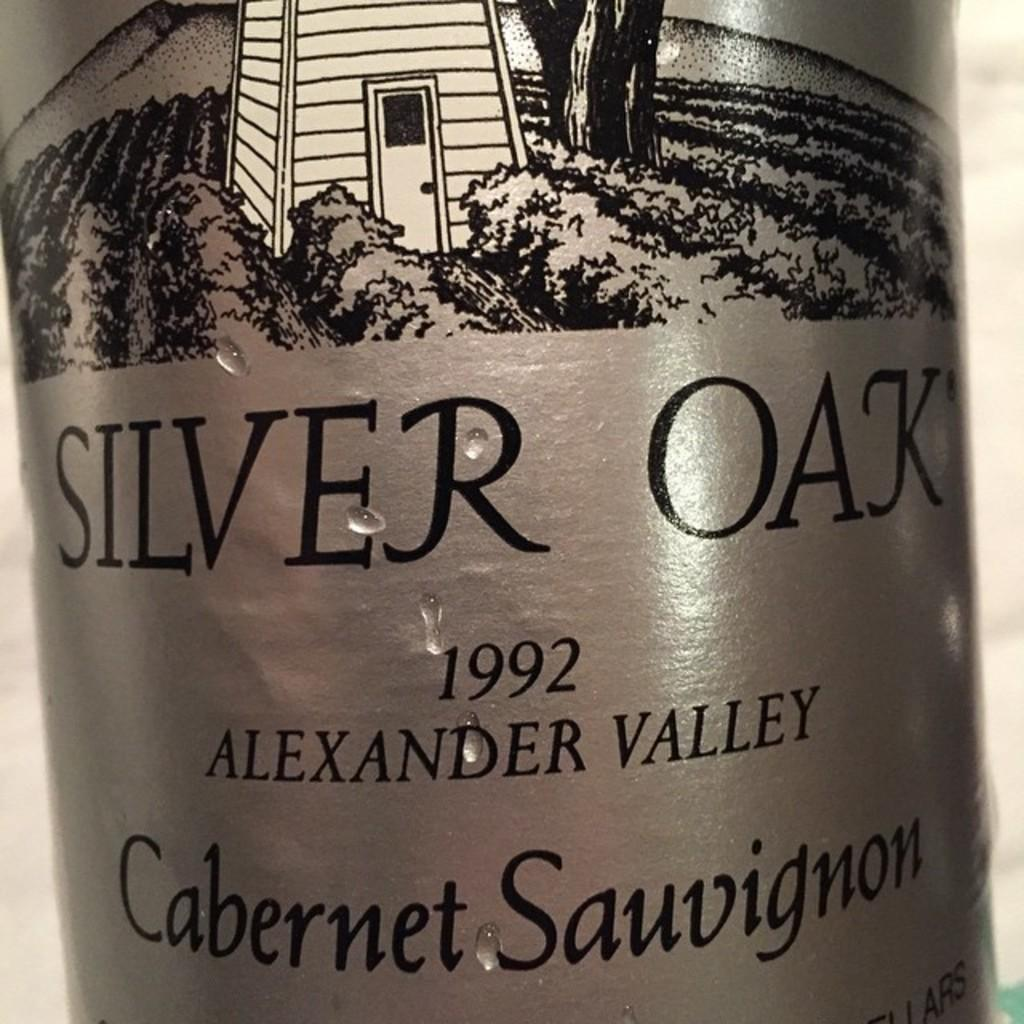<image>
Create a compact narrative representing the image presented. Silver Oak's 1992 cabernet sauvignon has a silver label with a picture of a vineyard on it. 